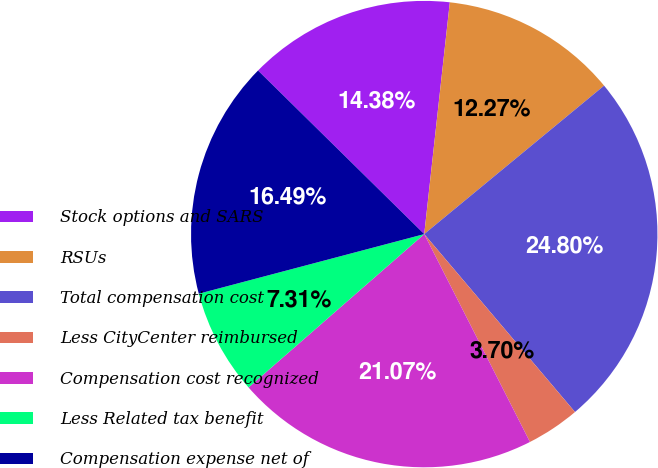<chart> <loc_0><loc_0><loc_500><loc_500><pie_chart><fcel>Stock options and SARS<fcel>RSUs<fcel>Total compensation cost<fcel>Less CityCenter reimbursed<fcel>Compensation cost recognized<fcel>Less Related tax benefit<fcel>Compensation expense net of<nl><fcel>14.38%<fcel>12.27%<fcel>24.8%<fcel>3.7%<fcel>21.07%<fcel>7.31%<fcel>16.49%<nl></chart> 